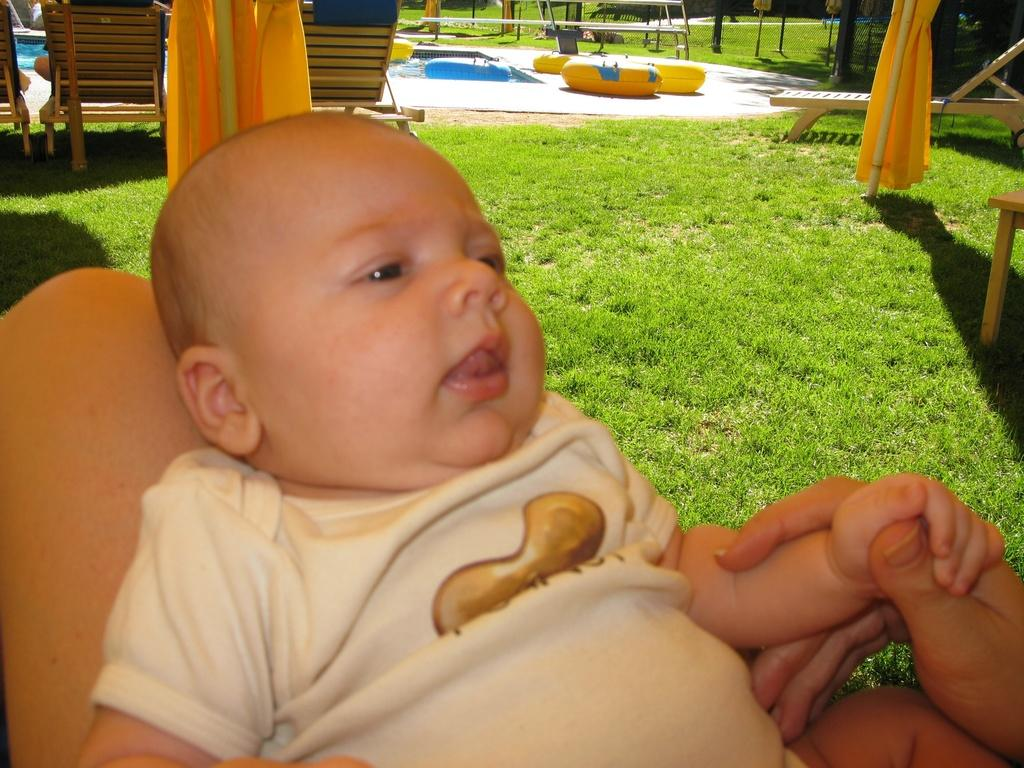What type of outdoor space is depicted in the image? There is a garden in the image. What other features can be seen in the garden? There are objects, a swimming pool, and grass present in the image. How many chairs are in the image? There are three chairs in the image. Can you describe the baby's position in the image? The baby is lying on someone's lap in the image and is holding a hand. What type of pot can be seen in the downtown area in the image? There is no downtown area or pot present in the image. How many times can the baby lift the hand in the image? The baby is not lifting a hand in the image; they are holding a hand. 